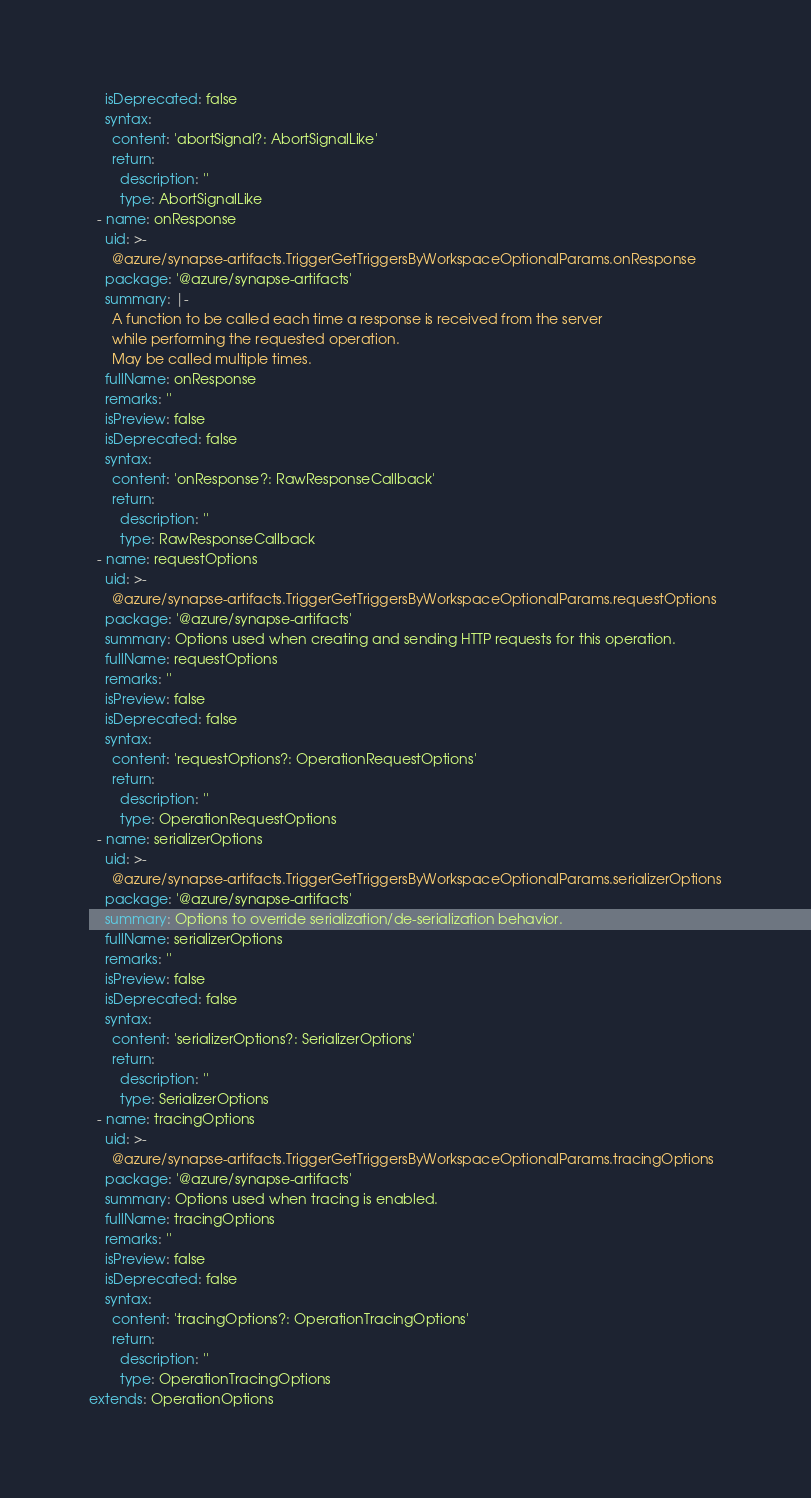<code> <loc_0><loc_0><loc_500><loc_500><_YAML_>    isDeprecated: false
    syntax:
      content: 'abortSignal?: AbortSignalLike'
      return:
        description: ''
        type: AbortSignalLike
  - name: onResponse
    uid: >-
      @azure/synapse-artifacts.TriggerGetTriggersByWorkspaceOptionalParams.onResponse
    package: '@azure/synapse-artifacts'
    summary: |-
      A function to be called each time a response is received from the server
      while performing the requested operation.
      May be called multiple times.
    fullName: onResponse
    remarks: ''
    isPreview: false
    isDeprecated: false
    syntax:
      content: 'onResponse?: RawResponseCallback'
      return:
        description: ''
        type: RawResponseCallback
  - name: requestOptions
    uid: >-
      @azure/synapse-artifacts.TriggerGetTriggersByWorkspaceOptionalParams.requestOptions
    package: '@azure/synapse-artifacts'
    summary: Options used when creating and sending HTTP requests for this operation.
    fullName: requestOptions
    remarks: ''
    isPreview: false
    isDeprecated: false
    syntax:
      content: 'requestOptions?: OperationRequestOptions'
      return:
        description: ''
        type: OperationRequestOptions
  - name: serializerOptions
    uid: >-
      @azure/synapse-artifacts.TriggerGetTriggersByWorkspaceOptionalParams.serializerOptions
    package: '@azure/synapse-artifacts'
    summary: Options to override serialization/de-serialization behavior.
    fullName: serializerOptions
    remarks: ''
    isPreview: false
    isDeprecated: false
    syntax:
      content: 'serializerOptions?: SerializerOptions'
      return:
        description: ''
        type: SerializerOptions
  - name: tracingOptions
    uid: >-
      @azure/synapse-artifacts.TriggerGetTriggersByWorkspaceOptionalParams.tracingOptions
    package: '@azure/synapse-artifacts'
    summary: Options used when tracing is enabled.
    fullName: tracingOptions
    remarks: ''
    isPreview: false
    isDeprecated: false
    syntax:
      content: 'tracingOptions?: OperationTracingOptions'
      return:
        description: ''
        type: OperationTracingOptions
extends: OperationOptions
</code> 